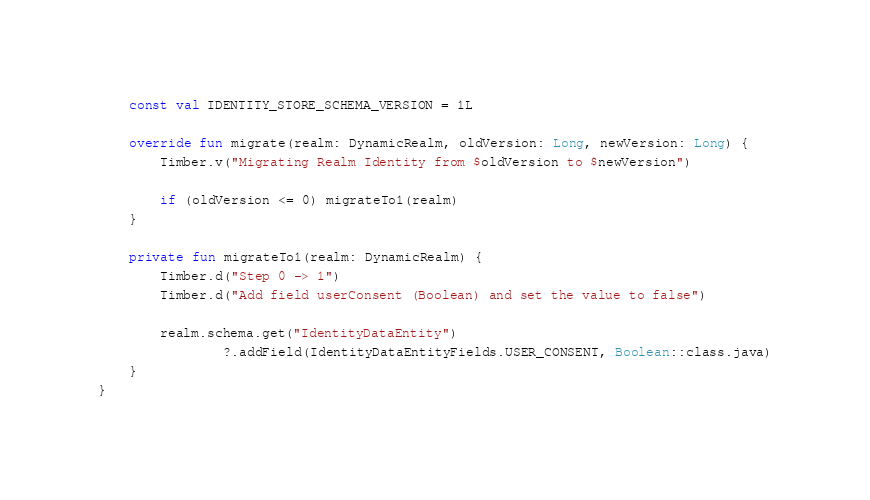Convert code to text. <code><loc_0><loc_0><loc_500><loc_500><_Kotlin_>    const val IDENTITY_STORE_SCHEMA_VERSION = 1L

    override fun migrate(realm: DynamicRealm, oldVersion: Long, newVersion: Long) {
        Timber.v("Migrating Realm Identity from $oldVersion to $newVersion")

        if (oldVersion <= 0) migrateTo1(realm)
    }

    private fun migrateTo1(realm: DynamicRealm) {
        Timber.d("Step 0 -> 1")
        Timber.d("Add field userConsent (Boolean) and set the value to false")

        realm.schema.get("IdentityDataEntity")
                ?.addField(IdentityDataEntityFields.USER_CONSENT, Boolean::class.java)
    }
}
</code> 